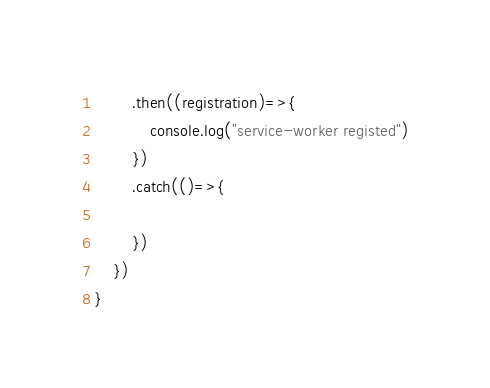<code> <loc_0><loc_0><loc_500><loc_500><_JavaScript_>        .then((registration)=>{
            console.log("service-worker registed")
        })
        .catch(()=>{
            
        })
    })
}</code> 